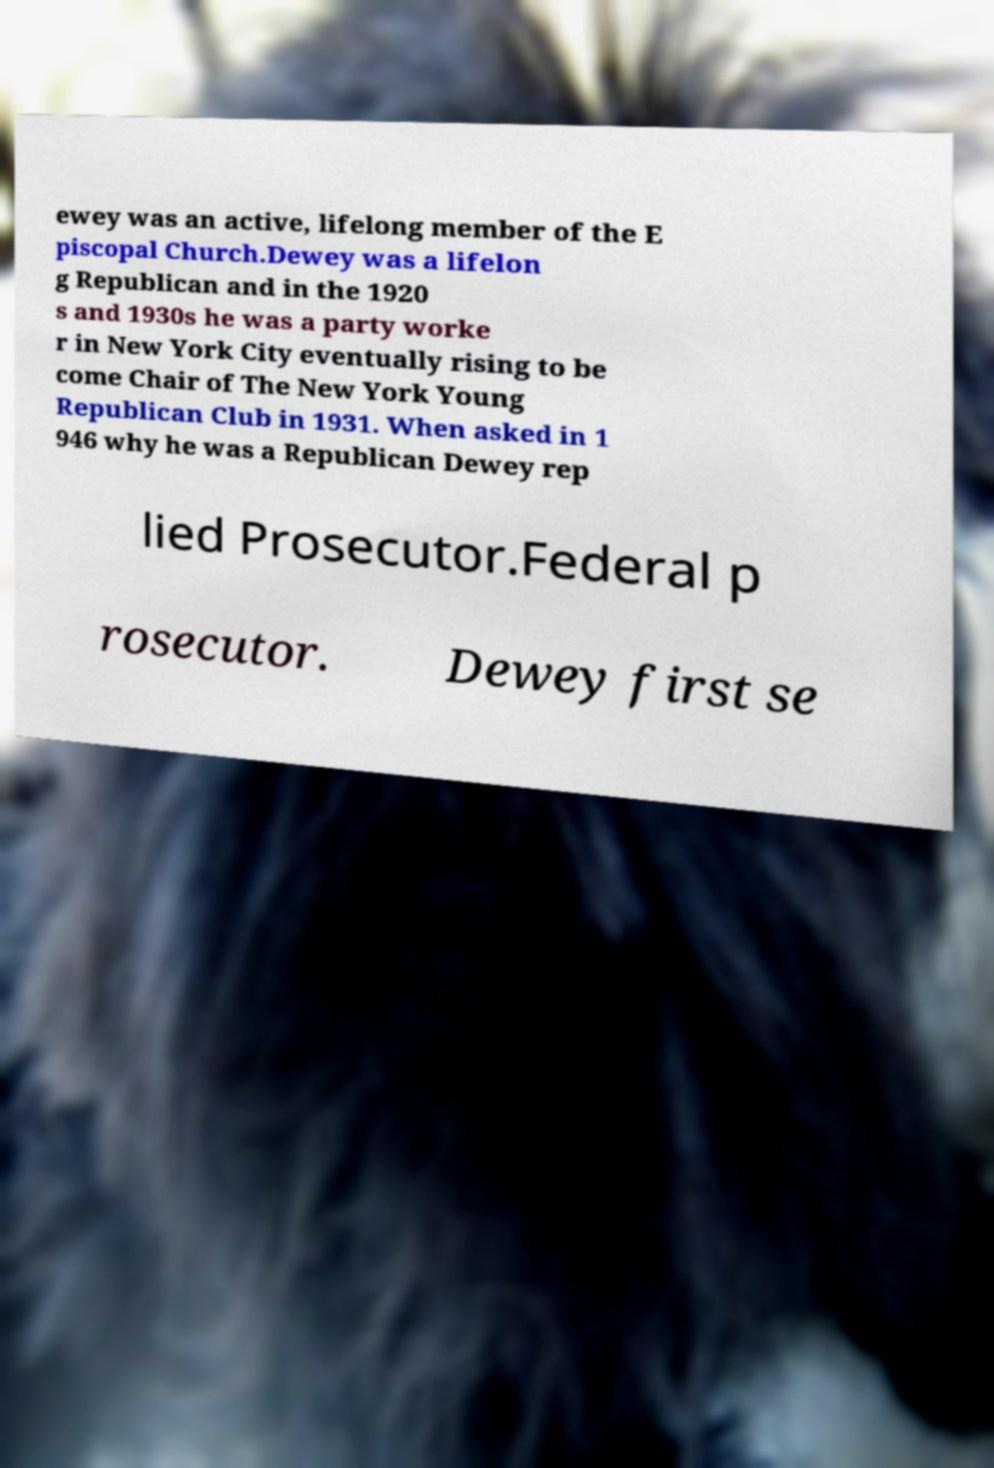Could you assist in decoding the text presented in this image and type it out clearly? ewey was an active, lifelong member of the E piscopal Church.Dewey was a lifelon g Republican and in the 1920 s and 1930s he was a party worke r in New York City eventually rising to be come Chair of The New York Young Republican Club in 1931. When asked in 1 946 why he was a Republican Dewey rep lied Prosecutor.Federal p rosecutor. Dewey first se 